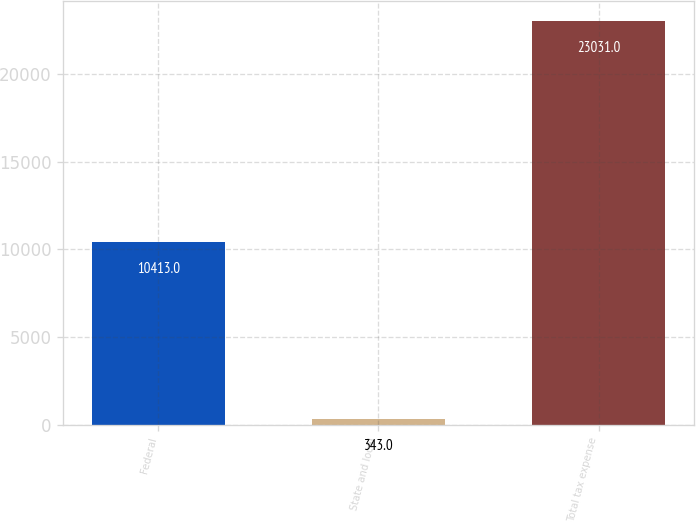Convert chart. <chart><loc_0><loc_0><loc_500><loc_500><bar_chart><fcel>Federal<fcel>State and local<fcel>Total tax expense<nl><fcel>10413<fcel>343<fcel>23031<nl></chart> 